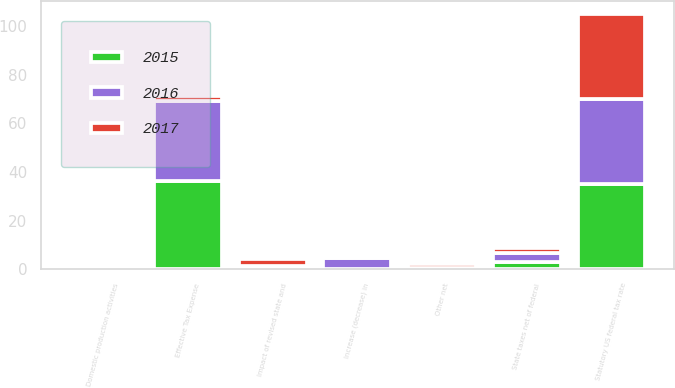Convert chart to OTSL. <chart><loc_0><loc_0><loc_500><loc_500><stacked_bar_chart><ecel><fcel>Statutory US federal tax rate<fcel>State taxes net of federal<fcel>Domestic production activities<fcel>Increase (decrease) in<fcel>Impact of revised state and<fcel>Other net<fcel>Effective Tax Expense<nl><fcel>2017<fcel>35<fcel>2.1<fcel>1<fcel>0.1<fcel>3.1<fcel>1.8<fcel>1.95<nl><fcel>2016<fcel>35<fcel>3.7<fcel>1.3<fcel>4.7<fcel>0.5<fcel>0.3<fcel>32.9<nl><fcel>2015<fcel>35<fcel>3<fcel>1.3<fcel>0.1<fcel>0.7<fcel>0.2<fcel>36.3<nl></chart> 